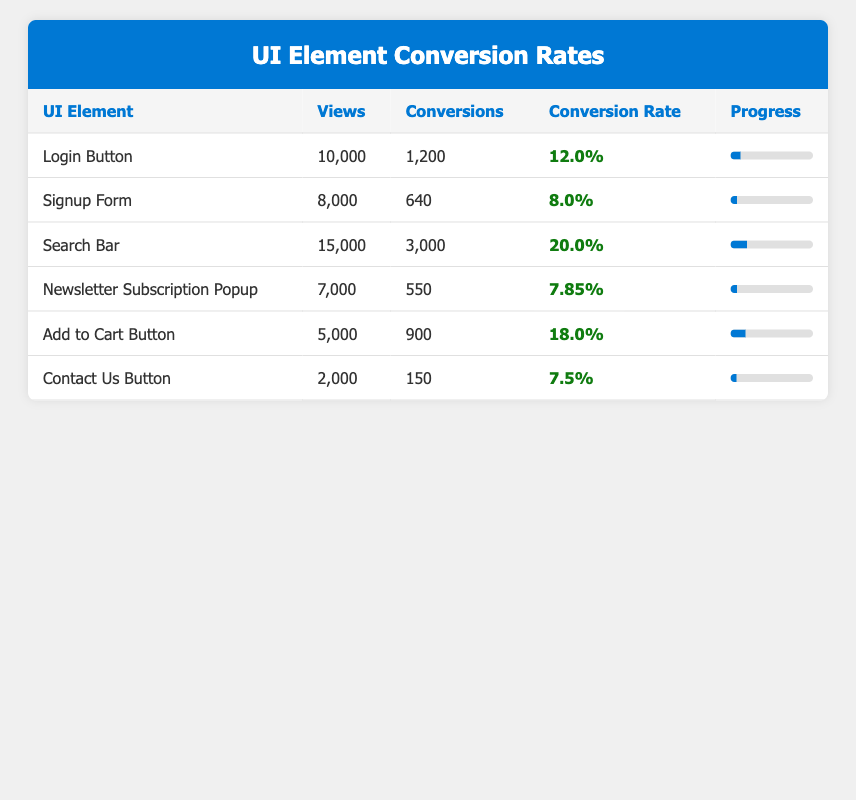What is the conversion rate of the Search Bar? The table shows that the conversion rate for the Search Bar is listed directly in the corresponding row as 20.0%.
Answer: 20.0% Which UI element has the highest number of views? By comparing the views across all UI elements, the Search Bar has the highest views at 15,000, which is greater than any other element listed.
Answer: Search Bar What is the total number of conversions from the Login Button and Add to Cart Button? The number of conversions from the Login Button is 1,200, and from the Add to Cart Button, it is 900. Adding these together gives 1,200 + 900 = 2,100.
Answer: 2,100 Is the conversion rate of the Newsletter Subscription Popup greater than the Signup Form? The conversion rate for the Newsletter Subscription Popup is 7.85%, and for the Signup Form, it is 8.0%. Since 7.85% is less than 8.0%, the statement is false.
Answer: No What is the average conversion rate of all the UI elements listed in the table? To calculate the average, sum the conversion rates: 12.0 + 8.0 + 20.0 + 7.85 + 18.0 + 7.5 = 73.35. Then divide by the number of UI elements, which is 6: 73.35 / 6 = 12.225.
Answer: 12.225 Which two UI elements combined have a total view count that exceeds 20,000? The views for the Login Button (10,000) and Search Bar (15,000) together equal 10,000 + 15,000 = 25,000, which exceeds 20,000.
Answer: Yes What percentage of views converted for the Contact Us Button? The conversion for the Contact Us Button is 150, and the views are 2,000. The conversion rate is calculated as (150 / 2000) * 100 = 7.5%. This is confirmed by the table, which directly states the conversion rate as 7.5%.
Answer: 7.5% Which UI element has the lowest conversion rate? By comparing the conversion rates listed in the table, the Newsletter Subscription Popup has the lowest conversion rate at 7.85%, lower than all other UI elements.
Answer: Newsletter Subscription Popup If the Signup Form had 9,000 views instead of 8,000, what would be its conversion rate assuming the conversions remain the same? With 9,000 views and 640 conversions, the new conversion rate would be calculated as (640 / 9000) * 100 = 7.11%. This is lower than the current 8.0%.
Answer: 7.11% 